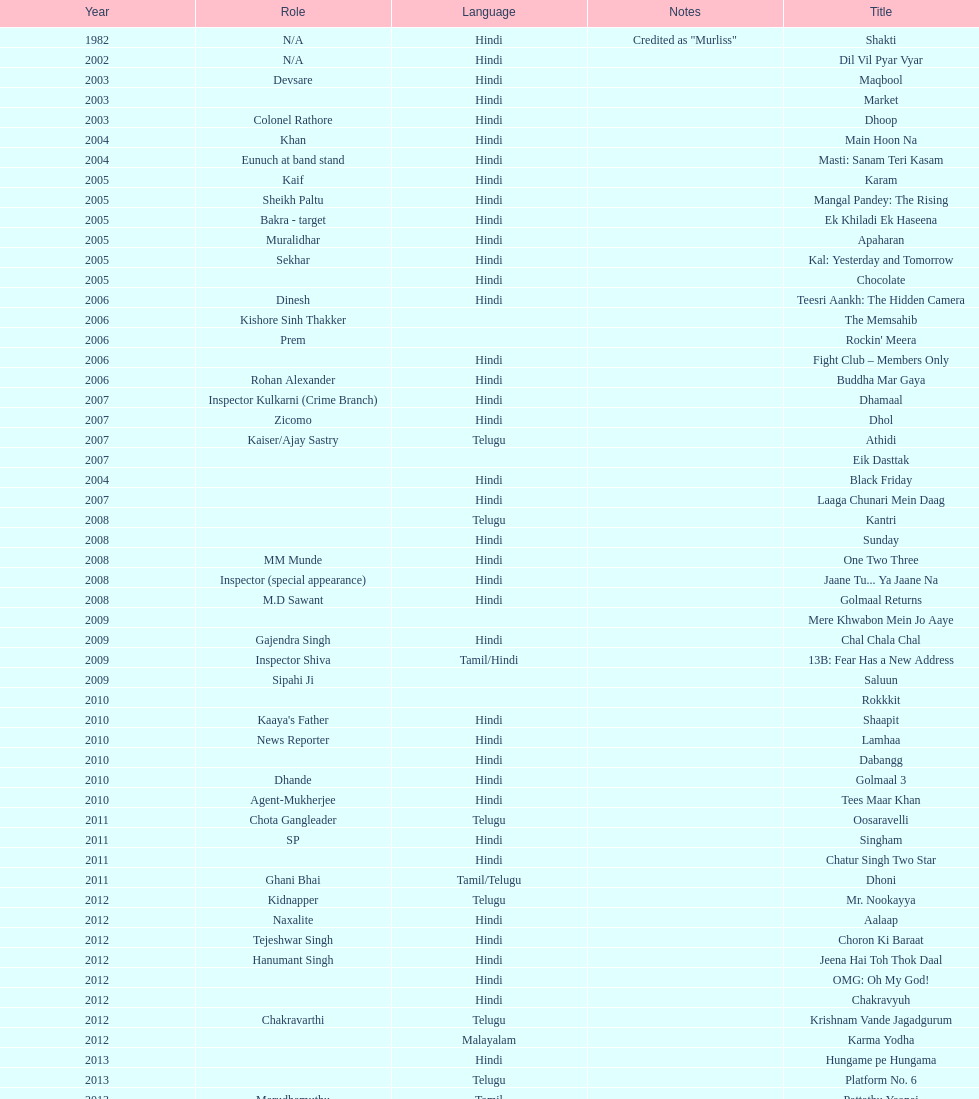What movie did this actor star in after they starred in dil vil pyar vyar in 2002? Maqbool. 